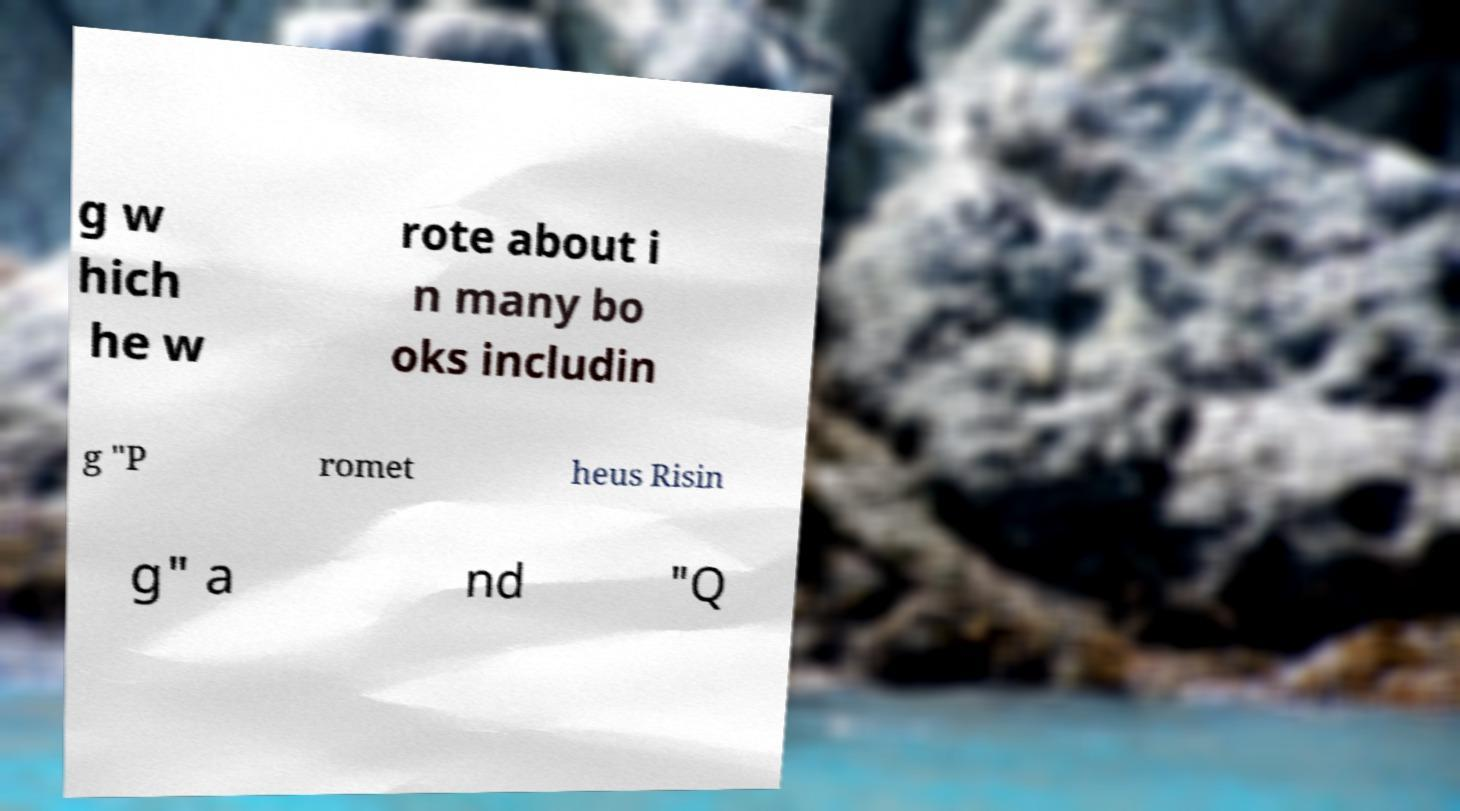There's text embedded in this image that I need extracted. Can you transcribe it verbatim? g w hich he w rote about i n many bo oks includin g "P romet heus Risin g" a nd "Q 